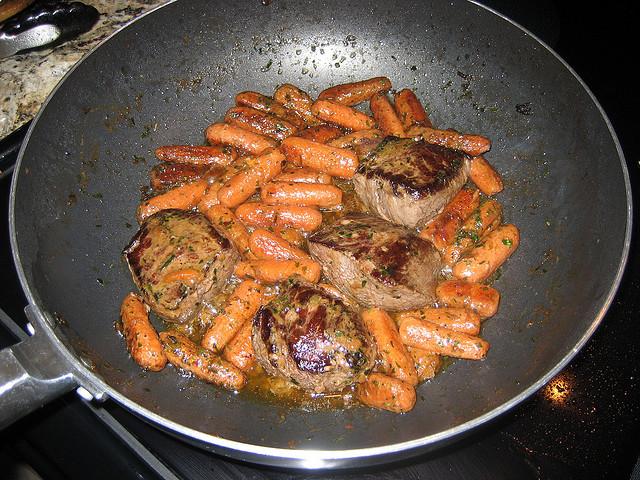What are the vegetables in the pan?
Write a very short answer. Carrots. What is everything cooking in?
Answer briefly. Wok. Is that chicken or fish?
Short answer required. Fish. 